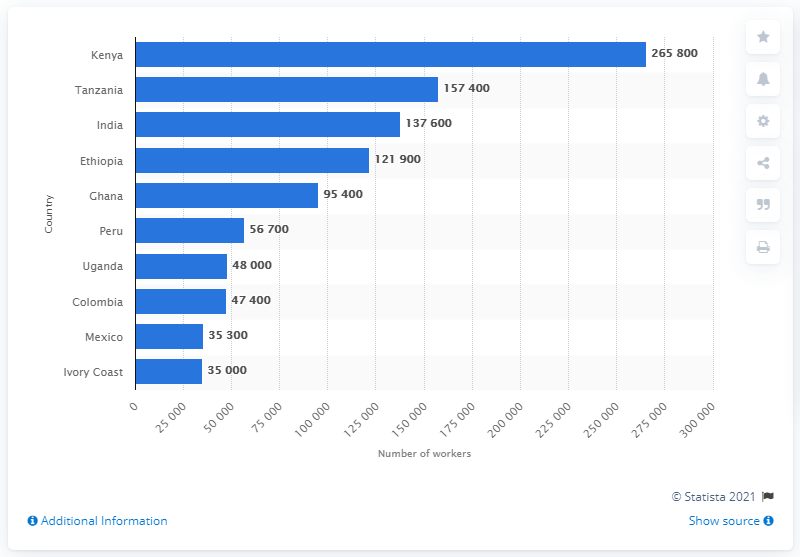Identify some key points in this picture. In 2012, Kenya was the top-ranked country with the most Fairtrade International farmers and workers. Ethiopia is in fourth place in the rank. The average ranking of the countries is 100050. 